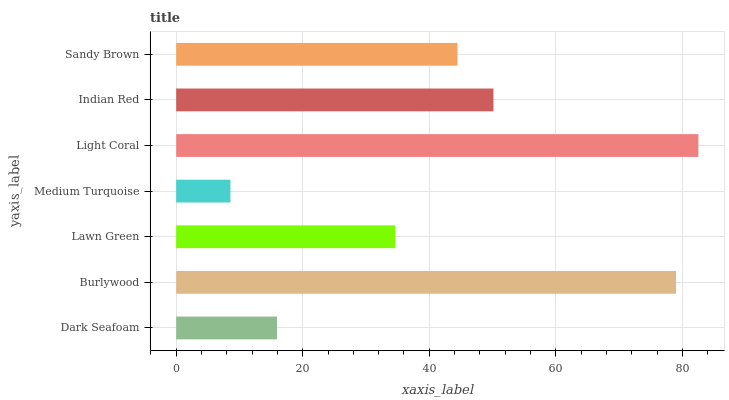Is Medium Turquoise the minimum?
Answer yes or no. Yes. Is Light Coral the maximum?
Answer yes or no. Yes. Is Burlywood the minimum?
Answer yes or no. No. Is Burlywood the maximum?
Answer yes or no. No. Is Burlywood greater than Dark Seafoam?
Answer yes or no. Yes. Is Dark Seafoam less than Burlywood?
Answer yes or no. Yes. Is Dark Seafoam greater than Burlywood?
Answer yes or no. No. Is Burlywood less than Dark Seafoam?
Answer yes or no. No. Is Sandy Brown the high median?
Answer yes or no. Yes. Is Sandy Brown the low median?
Answer yes or no. Yes. Is Burlywood the high median?
Answer yes or no. No. Is Medium Turquoise the low median?
Answer yes or no. No. 